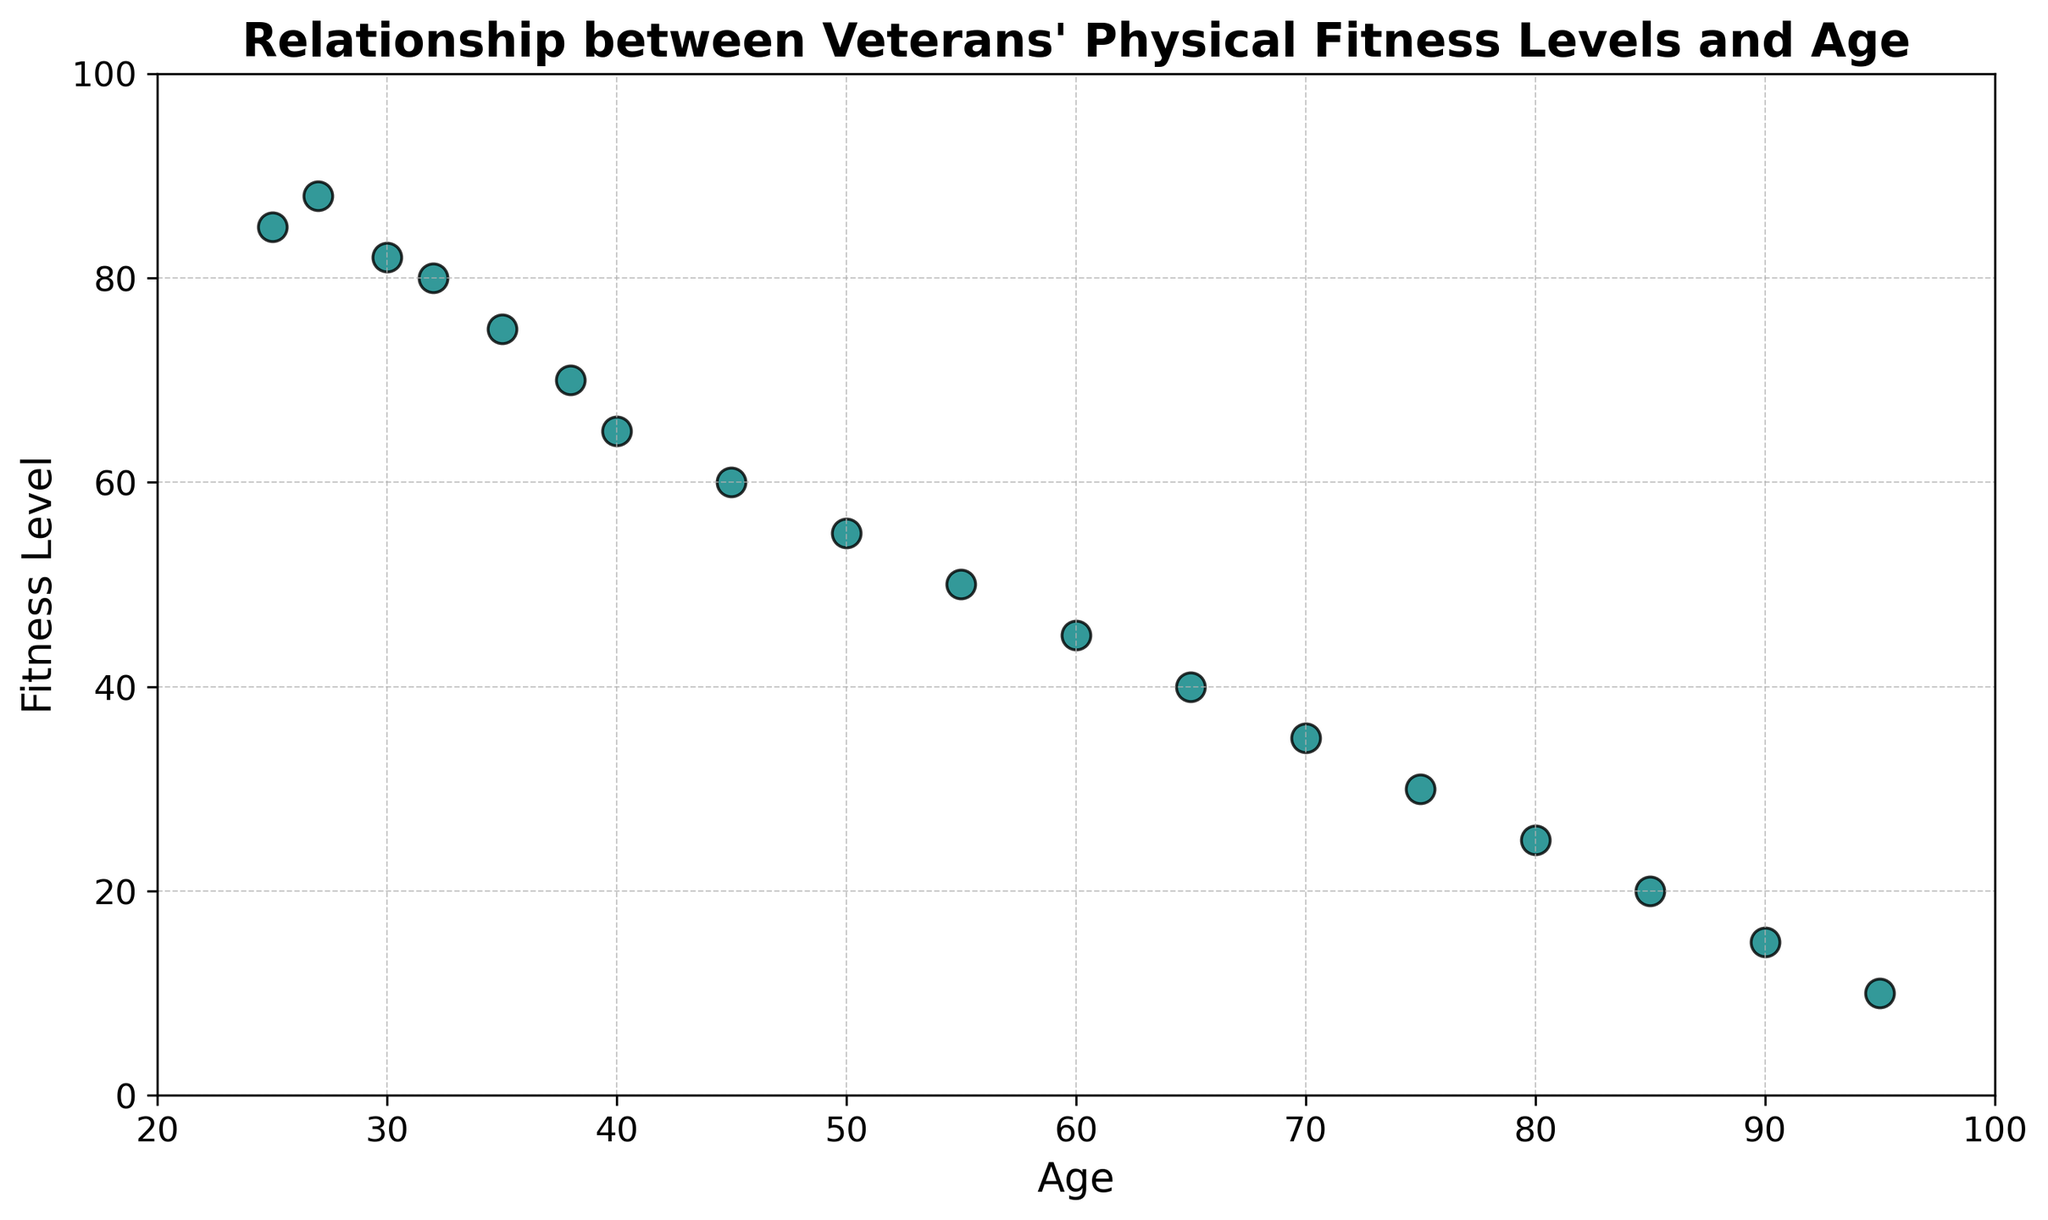What is the general trend in the relationship between age and fitness level for veterans? The overall pattern in the scatter plot shows a downward trend where the fitness level decreases as age increases. This indicates that older veterans generally have lower physical fitness levels compared to younger veterans.
Answer: Decreasing Is there a veteran who defies the general trend by having a high fitness level despite being older? By examining the scatter plot, you can look for data points where an older veteran has a significantly higher fitness level than those around them. However, in this plot, no older veteran (age 65 or older) has a fitness level substantially higher than the downward trend line.
Answer: No Which age group shows the most significant drop in fitness level? By looking at the scatter plot, the steepest drop in fitness levels appears between the ages of 30 and 45, where fitness levels drop from around 82 to 60.
Answer: 30 to 45 Compare the fitness levels of veterans aged 25 and 60. Find the points corresponding to ages 25 and 60. The fitness level for a 25-year-old is 85, whereas for a 60-year-old, it is 45. The younger veteran's fitness level is significantly higher.
Answer: 85 vs 45 What is the average fitness level for veterans aged 40, 50, and 60? First, identify the fitness levels: 40 is 65, 50 is 55, and 60 is 45. Add these values together (65 + 55 + 45 = 165) and divide by the number of points (3) to get the average.
Answer: 55 What is the median fitness level of the dataset? To find the median, list all fitness levels in ascending order: 10, 15, 20, 25, 30, 35, 40, 45, 50, 55, 60, 65, 70, 75, 80, 82, 85, 88. The middle value (9th and 10th in the list) is the median, found between 50 and 55.
Answer: 52.5 Is a 70-year-old veteran's fitness level closer to that of a 35-year-old or a 55-year-old? The fitness level for a 70-year-old is 35, for a 35-year-old is 75, and for a 55-year-old is 50. Calculate the differences: 75 - 35 = 40 and 50 - 35 = 15. The 70-year-old's fitness level is closer to that of a 55-year-old.
Answer: 55-year-old How many veterans aged 45 or older have a fitness level below 60? Check the scatter plot for points where age is 45 or older (45, 50, 55, 60, 65, 70, 75, 80, 85, 90, 95) and fitness levels below 60 (ages 45, 50, 55, 60, 65, 70, 75, 80, 85, 90, 95). There are 10 such points.
Answer: 10 Is there a significant visual clustering of data points in any particular age group? By visually inspecting the scatter plot, the data points are relatively spread out, but there is a visible cluster of points between the ages of 50 and 65, where fitness levels range from 40 to 60.
Answer: 50 to 65 